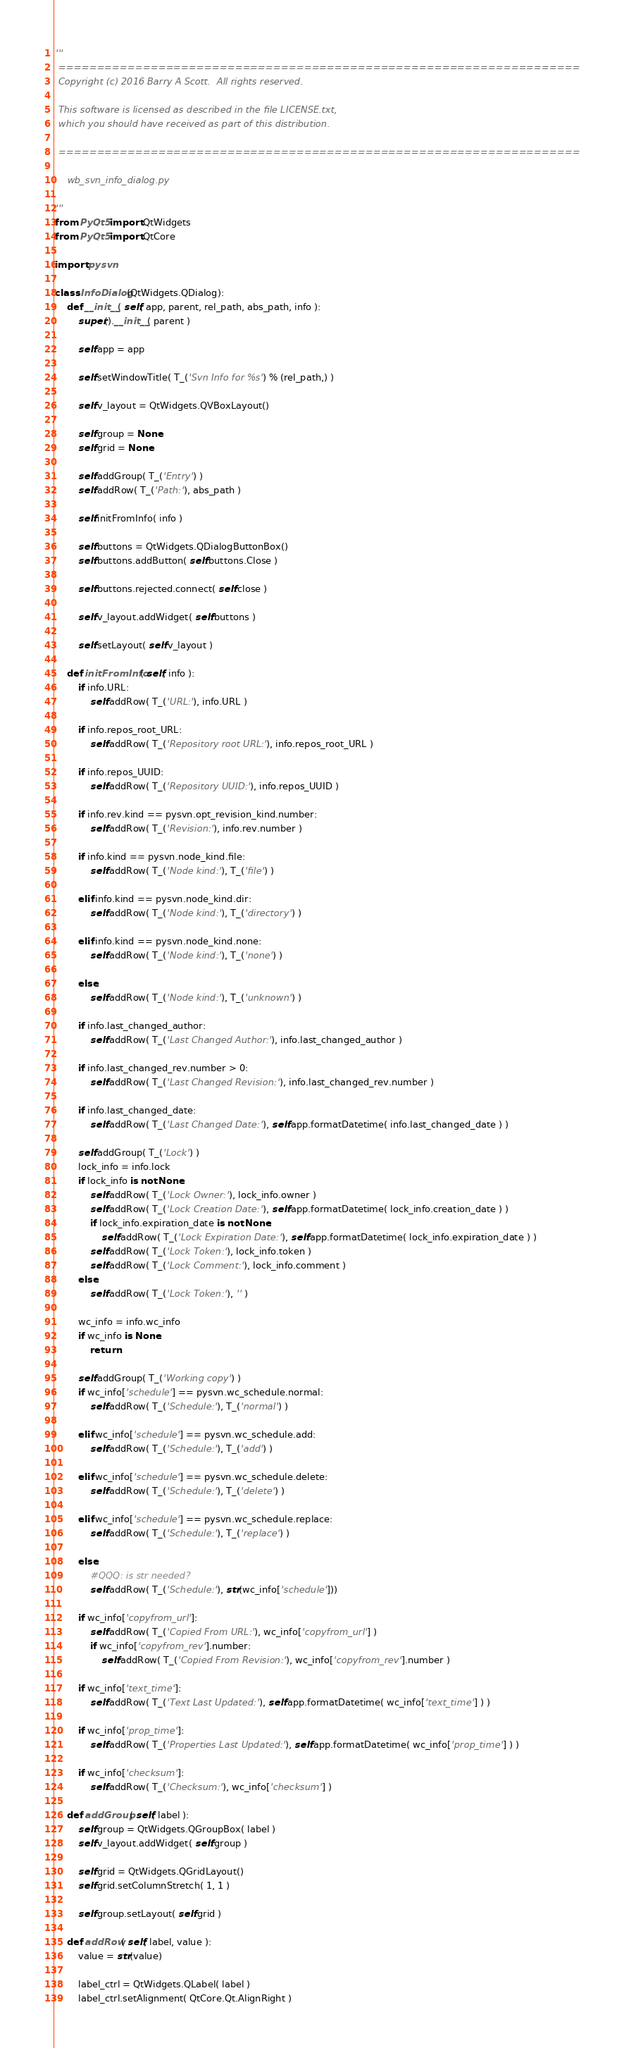<code> <loc_0><loc_0><loc_500><loc_500><_Python_>'''
 ====================================================================
 Copyright (c) 2016 Barry A Scott.  All rights reserved.

 This software is licensed as described in the file LICENSE.txt,
 which you should have received as part of this distribution.

 ====================================================================

    wb_svn_info_dialog.py

'''
from PyQt5 import QtWidgets
from PyQt5 import QtCore

import pysvn

class InfoDialog(QtWidgets.QDialog):
    def __init__( self, app, parent, rel_path, abs_path, info ):
        super().__init__( parent )

        self.app = app

        self.setWindowTitle( T_('Svn Info for %s') % (rel_path,) )

        self.v_layout = QtWidgets.QVBoxLayout()

        self.group = None
        self.grid = None

        self.addGroup( T_('Entry') )
        self.addRow( T_('Path:'), abs_path )

        self.initFromInfo( info )

        self.buttons = QtWidgets.QDialogButtonBox()
        self.buttons.addButton( self.buttons.Close )

        self.buttons.rejected.connect( self.close )

        self.v_layout.addWidget( self.buttons )

        self.setLayout( self.v_layout )

    def initFromInfo( self, info ):
        if info.URL:
            self.addRow( T_('URL:'), info.URL )

        if info.repos_root_URL:
            self.addRow( T_('Repository root URL:'), info.repos_root_URL )

        if info.repos_UUID:
            self.addRow( T_('Repository UUID:'), info.repos_UUID )

        if info.rev.kind == pysvn.opt_revision_kind.number:
            self.addRow( T_('Revision:'), info.rev.number )

        if info.kind == pysvn.node_kind.file:
            self.addRow( T_('Node kind:'), T_('file') )

        elif info.kind == pysvn.node_kind.dir:
            self.addRow( T_('Node kind:'), T_('directory') )

        elif info.kind == pysvn.node_kind.none:
            self.addRow( T_('Node kind:'), T_('none') )

        else:
            self.addRow( T_('Node kind:'), T_('unknown') )

        if info.last_changed_author:
            self.addRow( T_('Last Changed Author:'), info.last_changed_author )

        if info.last_changed_rev.number > 0:
            self.addRow( T_('Last Changed Revision:'), info.last_changed_rev.number )

        if info.last_changed_date:
            self.addRow( T_('Last Changed Date:'), self.app.formatDatetime( info.last_changed_date ) )

        self.addGroup( T_('Lock') )
        lock_info = info.lock
        if lock_info is not None:
            self.addRow( T_('Lock Owner:'), lock_info.owner )
            self.addRow( T_('Lock Creation Date:'), self.app.formatDatetime( lock_info.creation_date ) )
            if lock_info.expiration_date is not None:
                self.addRow( T_('Lock Expiration Date:'), self.app.formatDatetime( lock_info.expiration_date ) )
            self.addRow( T_('Lock Token:'), lock_info.token )
            self.addRow( T_('Lock Comment:'), lock_info.comment )
        else:
            self.addRow( T_('Lock Token:'), '' )

        wc_info = info.wc_info
        if wc_info is None:
            return

        self.addGroup( T_('Working copy') )
        if wc_info['schedule'] == pysvn.wc_schedule.normal:
            self.addRow( T_('Schedule:'), T_('normal') )

        elif wc_info['schedule'] == pysvn.wc_schedule.add:
            self.addRow( T_('Schedule:'), T_('add') )

        elif wc_info['schedule'] == pysvn.wc_schedule.delete:
            self.addRow( T_('Schedule:'), T_('delete') )

        elif wc_info['schedule'] == pysvn.wc_schedule.replace:
            self.addRow( T_('Schedule:'), T_('replace') )

        else:
            #QQQ: is str needed?
            self.addRow( T_('Schedule:'), str(wc_info['schedule']))

        if wc_info['copyfrom_url']:
            self.addRow( T_('Copied From URL:'), wc_info['copyfrom_url'] )
            if wc_info['copyfrom_rev'].number:
                self.addRow( T_('Copied From Revision:'), wc_info['copyfrom_rev'].number )

        if wc_info['text_time']:
            self.addRow( T_('Text Last Updated:'), self.app.formatDatetime( wc_info['text_time'] ) )

        if wc_info['prop_time']:
            self.addRow( T_('Properties Last Updated:'), self.app.formatDatetime( wc_info['prop_time'] ) )

        if wc_info['checksum']:
            self.addRow( T_('Checksum:'), wc_info['checksum'] )

    def addGroup( self, label ):
        self.group = QtWidgets.QGroupBox( label )
        self.v_layout.addWidget( self.group )

        self.grid = QtWidgets.QGridLayout()
        self.grid.setColumnStretch( 1, 1 )

        self.group.setLayout( self.grid )

    def addRow( self, label, value ):
        value = str(value)

        label_ctrl = QtWidgets.QLabel( label )
        label_ctrl.setAlignment( QtCore.Qt.AlignRight )
</code> 